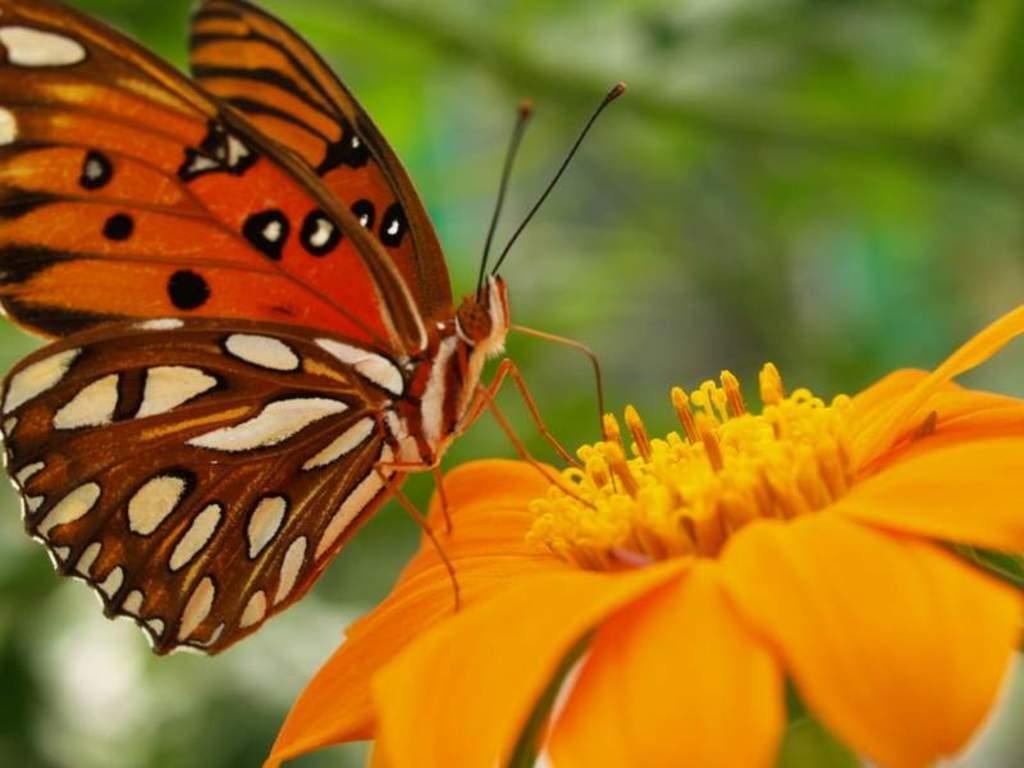What is the main subject of the image? The main subject of the image is a butterfly. Where is the butterfly located in the image? The butterfly is on a flower. Can you describe the background of the image? The background of the image is blurred. What type of yarn is the butterfly using to make a decision in the image? There is no yarn or decision-making process depicted in the image; it simply features a butterfly on a flower. 